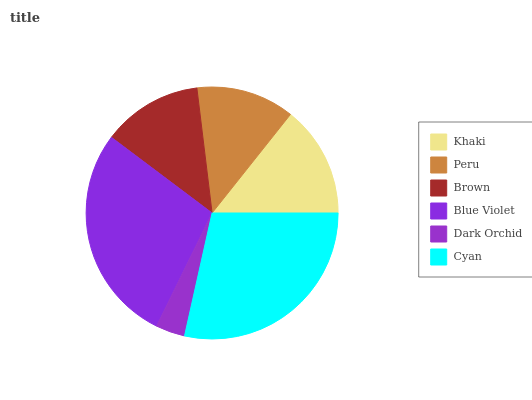Is Dark Orchid the minimum?
Answer yes or no. Yes. Is Cyan the maximum?
Answer yes or no. Yes. Is Peru the minimum?
Answer yes or no. No. Is Peru the maximum?
Answer yes or no. No. Is Khaki greater than Peru?
Answer yes or no. Yes. Is Peru less than Khaki?
Answer yes or no. Yes. Is Peru greater than Khaki?
Answer yes or no. No. Is Khaki less than Peru?
Answer yes or no. No. Is Khaki the high median?
Answer yes or no. Yes. Is Brown the low median?
Answer yes or no. Yes. Is Peru the high median?
Answer yes or no. No. Is Blue Violet the low median?
Answer yes or no. No. 